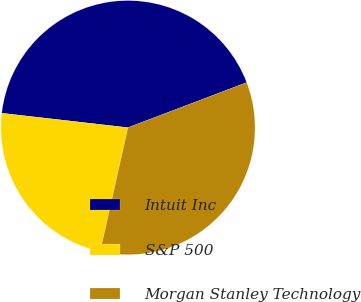Convert chart to OTSL. <chart><loc_0><loc_0><loc_500><loc_500><pie_chart><fcel>Intuit Inc<fcel>S&P 500<fcel>Morgan Stanley Technology<nl><fcel>42.41%<fcel>23.3%<fcel>34.29%<nl></chart> 